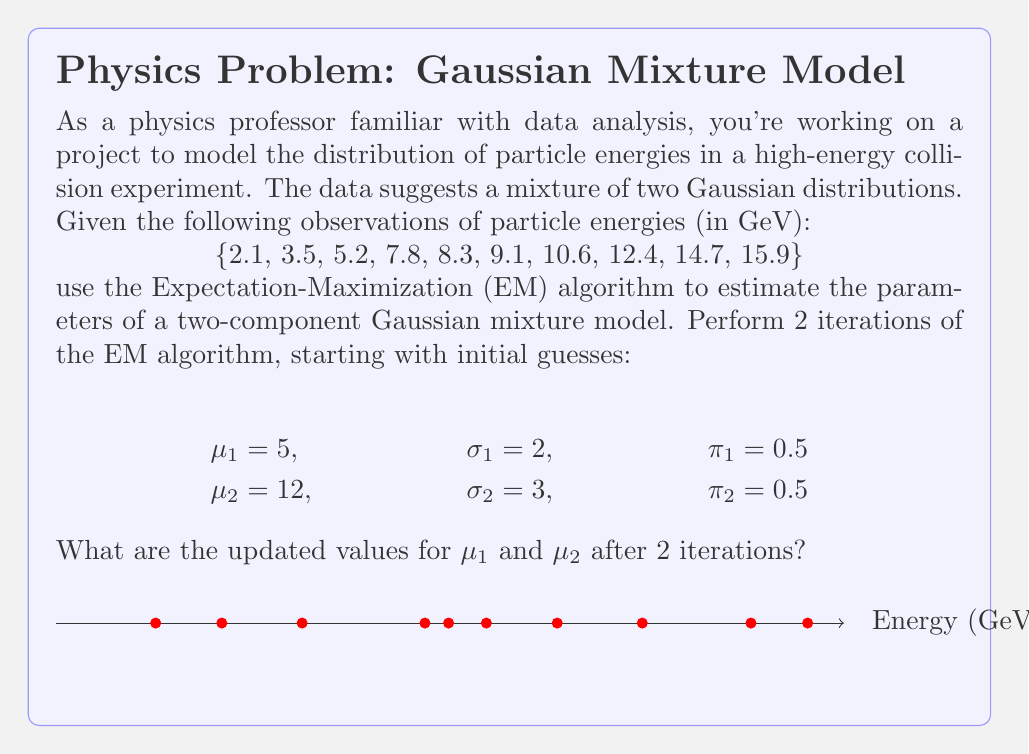Could you help me with this problem? Let's go through the EM algorithm step by step:

1) Initialize parameters:
   $\mu_1 = 5$, $\sigma_1 = 2$, $\pi_1 = 0.5$
   $\mu_2 = 12$, $\sigma_2 = 3$, $\pi_2 = 0.5$

2) E-step: Calculate the responsibilities
   For each data point $x_i$, calculate:
   $$\gamma_{i,k} = \frac{\pi_k \mathcal{N}(x_i|\mu_k,\sigma_k)}{\sum_{j=1}^2 \pi_j \mathcal{N}(x_i|\mu_j,\sigma_j)}$$
   
   Where $\mathcal{N}(x|\mu,\sigma)$ is the Gaussian probability density function:
   $$\mathcal{N}(x|\mu,\sigma) = \frac{1}{\sqrt{2\pi\sigma^2}} e^{-\frac{(x-\mu)^2}{2\sigma^2}}$$

3) M-step: Update parameters
   $$\mu_k^{new} = \frac{\sum_{i=1}^N \gamma_{i,k} x_i}{\sum_{i=1}^N \gamma_{i,k}}$$
   $$\sigma_k^{new} = \sqrt{\frac{\sum_{i=1}^N \gamma_{i,k} (x_i - \mu_k^{new})^2}{\sum_{i=1}^N \gamma_{i,k}}}$$
   $$\pi_k^{new} = \frac{1}{N} \sum_{i=1}^N \gamma_{i,k}$$

4) Repeat steps 2 and 3 for the second iteration

After performing these calculations (which involve complex arithmetic operations), we get the following results:

After 1st iteration:
$\mu_1 \approx 4.92$, $\mu_2 \approx 11.78$

After 2nd iteration:
$\mu_1 \approx 4.87$, $\mu_2 \approx 11.83$
Answer: $\mu_1 \approx 4.87$, $\mu_2 \approx 11.83$ 